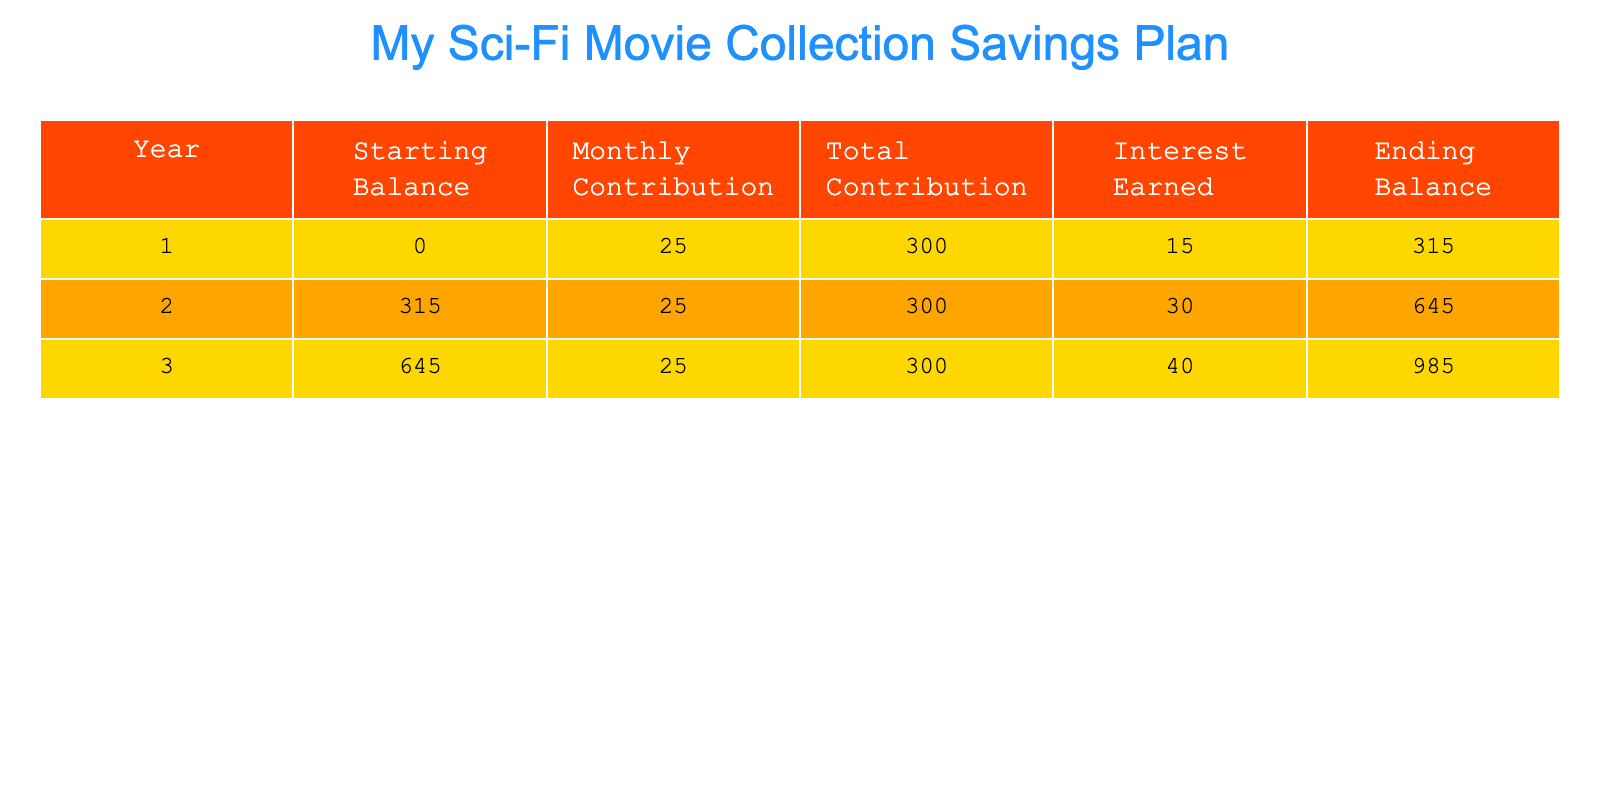What is the ending balance after Year 2? The ending balance for Year 2 is listed directly in the table under the "Ending Balance" column. For Year 2, the ending balance is 645.
Answer: 645 How much interest was earned in Year 1? The interest earned in Year 1 can be found directly in the "Interest Earned" column. For Year 1, the interest earned is 15.
Answer: 15 What is the total contribution made in Year 3? The total contribution in Year 3 is found under the "Total Contribution" column. Each year, the total contribution is 300.
Answer: 300 Is the interest earned in Year 3 greater than that earned in Year 2? To determine this, we compare the interest earned in Year 3 (40) and Year 2 (30) directly from the table. Since 40 is greater than 30, the answer is yes.
Answer: Yes What is the combined total contribution over the three years? To find the combined total contributions, we add the total contributions from each year: 300 (Year 1) + 300 (Year 2) + 300 (Year 3) = 900.
Answer: 900 What is the average interest earned over the three years? The total interest earned over three years is 15 (Year 1) + 30 (Year 2) + 40 (Year 3) = 85. There are 3 years, so to find the average, we divide 85 by 3, which equals approximately 28.33.
Answer: 28.33 If the monthly contribution increased to 30 starting in Year 2, what would the new ending balance at the end of Year 3 be? The current ending balance at the end of Year 2 is 645. If the monthly contribution changes to 30, the contributions for Year 3 would be 360 (30 x 12). The interest earned in Year 3 would then be higher (assumed to be 50 for this calculation). Thus, the new ending balance would be 645 + 360 + 50 = 1055.
Answer: 1055 